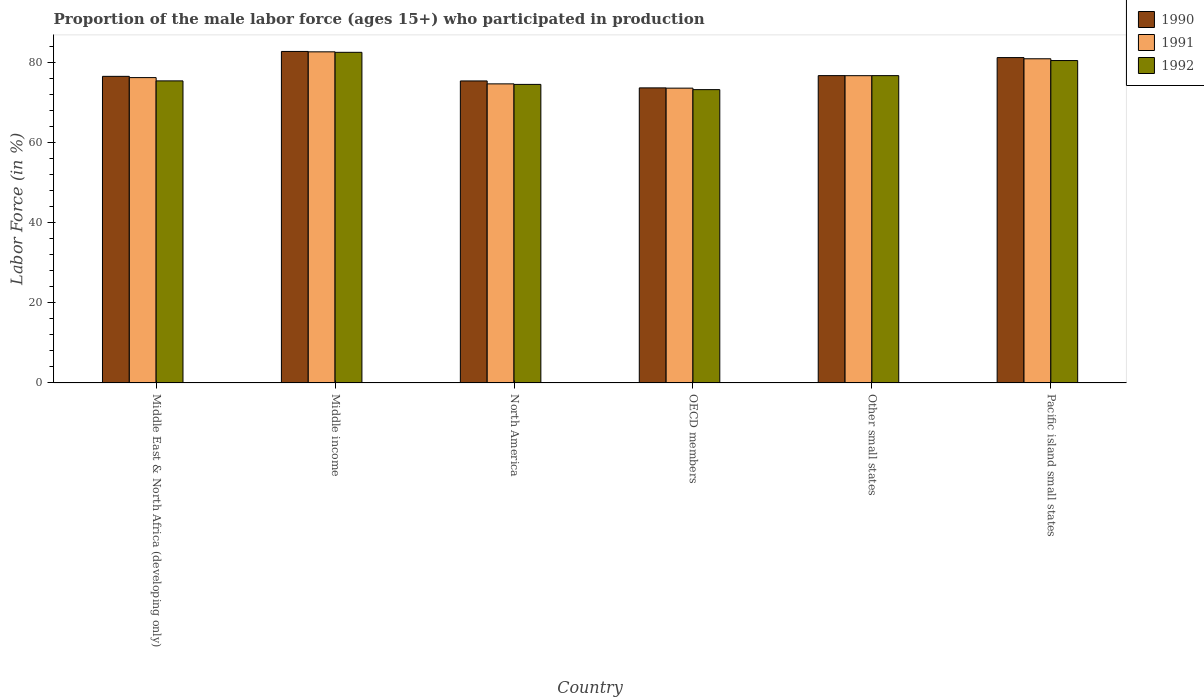How many groups of bars are there?
Provide a succinct answer. 6. How many bars are there on the 2nd tick from the left?
Give a very brief answer. 3. What is the label of the 6th group of bars from the left?
Your response must be concise. Pacific island small states. What is the proportion of the male labor force who participated in production in 1991 in Pacific island small states?
Ensure brevity in your answer.  81. Across all countries, what is the maximum proportion of the male labor force who participated in production in 1990?
Offer a terse response. 82.83. Across all countries, what is the minimum proportion of the male labor force who participated in production in 1990?
Keep it short and to the point. 73.73. What is the total proportion of the male labor force who participated in production in 1992 in the graph?
Your answer should be very brief. 463.32. What is the difference between the proportion of the male labor force who participated in production in 1991 in North America and that in Other small states?
Provide a succinct answer. -2.04. What is the difference between the proportion of the male labor force who participated in production in 1991 in OECD members and the proportion of the male labor force who participated in production in 1992 in North America?
Keep it short and to the point. -0.94. What is the average proportion of the male labor force who participated in production in 1990 per country?
Offer a very short reply. 77.79. What is the difference between the proportion of the male labor force who participated in production of/in 1990 and proportion of the male labor force who participated in production of/in 1992 in Middle East & North Africa (developing only)?
Provide a short and direct response. 1.13. In how many countries, is the proportion of the male labor force who participated in production in 1992 greater than 76 %?
Your answer should be compact. 3. What is the ratio of the proportion of the male labor force who participated in production in 1992 in Middle income to that in OECD members?
Your response must be concise. 1.13. Is the difference between the proportion of the male labor force who participated in production in 1990 in Other small states and Pacific island small states greater than the difference between the proportion of the male labor force who participated in production in 1992 in Other small states and Pacific island small states?
Offer a terse response. No. What is the difference between the highest and the second highest proportion of the male labor force who participated in production in 1990?
Ensure brevity in your answer.  -1.54. What is the difference between the highest and the lowest proportion of the male labor force who participated in production in 1991?
Your answer should be very brief. 9.07. How many countries are there in the graph?
Provide a succinct answer. 6. Are the values on the major ticks of Y-axis written in scientific E-notation?
Give a very brief answer. No. Does the graph contain any zero values?
Ensure brevity in your answer.  No. How are the legend labels stacked?
Offer a very short reply. Vertical. What is the title of the graph?
Give a very brief answer. Proportion of the male labor force (ages 15+) who participated in production. What is the Labor Force (in %) of 1990 in Middle East & North Africa (developing only)?
Offer a terse response. 76.61. What is the Labor Force (in %) of 1991 in Middle East & North Africa (developing only)?
Your answer should be very brief. 76.29. What is the Labor Force (in %) in 1992 in Middle East & North Africa (developing only)?
Keep it short and to the point. 75.48. What is the Labor Force (in %) in 1990 in Middle income?
Keep it short and to the point. 82.83. What is the Labor Force (in %) of 1991 in Middle income?
Ensure brevity in your answer.  82.73. What is the Labor Force (in %) of 1992 in Middle income?
Provide a succinct answer. 82.61. What is the Labor Force (in %) in 1990 in North America?
Keep it short and to the point. 75.46. What is the Labor Force (in %) in 1991 in North America?
Offer a terse response. 74.73. What is the Labor Force (in %) of 1992 in North America?
Your answer should be very brief. 74.6. What is the Labor Force (in %) in 1990 in OECD members?
Provide a succinct answer. 73.73. What is the Labor Force (in %) of 1991 in OECD members?
Provide a succinct answer. 73.66. What is the Labor Force (in %) of 1992 in OECD members?
Your response must be concise. 73.29. What is the Labor Force (in %) in 1990 in Other small states?
Keep it short and to the point. 76.79. What is the Labor Force (in %) of 1991 in Other small states?
Provide a succinct answer. 76.78. What is the Labor Force (in %) in 1992 in Other small states?
Offer a very short reply. 76.79. What is the Labor Force (in %) of 1990 in Pacific island small states?
Your answer should be very brief. 81.29. What is the Labor Force (in %) in 1991 in Pacific island small states?
Make the answer very short. 81. What is the Labor Force (in %) in 1992 in Pacific island small states?
Ensure brevity in your answer.  80.56. Across all countries, what is the maximum Labor Force (in %) in 1990?
Give a very brief answer. 82.83. Across all countries, what is the maximum Labor Force (in %) of 1991?
Your answer should be very brief. 82.73. Across all countries, what is the maximum Labor Force (in %) of 1992?
Make the answer very short. 82.61. Across all countries, what is the minimum Labor Force (in %) of 1990?
Provide a succinct answer. 73.73. Across all countries, what is the minimum Labor Force (in %) of 1991?
Give a very brief answer. 73.66. Across all countries, what is the minimum Labor Force (in %) in 1992?
Provide a succinct answer. 73.29. What is the total Labor Force (in %) of 1990 in the graph?
Offer a terse response. 466.71. What is the total Labor Force (in %) in 1991 in the graph?
Your answer should be very brief. 465.19. What is the total Labor Force (in %) in 1992 in the graph?
Keep it short and to the point. 463.32. What is the difference between the Labor Force (in %) in 1990 in Middle East & North Africa (developing only) and that in Middle income?
Provide a succinct answer. -6.22. What is the difference between the Labor Force (in %) of 1991 in Middle East & North Africa (developing only) and that in Middle income?
Provide a short and direct response. -6.44. What is the difference between the Labor Force (in %) of 1992 in Middle East & North Africa (developing only) and that in Middle income?
Offer a very short reply. -7.14. What is the difference between the Labor Force (in %) of 1990 in Middle East & North Africa (developing only) and that in North America?
Provide a short and direct response. 1.15. What is the difference between the Labor Force (in %) of 1991 in Middle East & North Africa (developing only) and that in North America?
Offer a terse response. 1.56. What is the difference between the Labor Force (in %) of 1992 in Middle East & North Africa (developing only) and that in North America?
Ensure brevity in your answer.  0.88. What is the difference between the Labor Force (in %) of 1990 in Middle East & North Africa (developing only) and that in OECD members?
Your response must be concise. 2.88. What is the difference between the Labor Force (in %) in 1991 in Middle East & North Africa (developing only) and that in OECD members?
Offer a very short reply. 2.64. What is the difference between the Labor Force (in %) in 1992 in Middle East & North Africa (developing only) and that in OECD members?
Your answer should be compact. 2.19. What is the difference between the Labor Force (in %) in 1990 in Middle East & North Africa (developing only) and that in Other small states?
Make the answer very short. -0.18. What is the difference between the Labor Force (in %) in 1991 in Middle East & North Africa (developing only) and that in Other small states?
Your response must be concise. -0.48. What is the difference between the Labor Force (in %) of 1992 in Middle East & North Africa (developing only) and that in Other small states?
Ensure brevity in your answer.  -1.31. What is the difference between the Labor Force (in %) in 1990 in Middle East & North Africa (developing only) and that in Pacific island small states?
Ensure brevity in your answer.  -4.69. What is the difference between the Labor Force (in %) in 1991 in Middle East & North Africa (developing only) and that in Pacific island small states?
Offer a very short reply. -4.71. What is the difference between the Labor Force (in %) of 1992 in Middle East & North Africa (developing only) and that in Pacific island small states?
Your response must be concise. -5.08. What is the difference between the Labor Force (in %) in 1990 in Middle income and that in North America?
Give a very brief answer. 7.37. What is the difference between the Labor Force (in %) in 1991 in Middle income and that in North America?
Your answer should be compact. 8. What is the difference between the Labor Force (in %) of 1992 in Middle income and that in North America?
Provide a short and direct response. 8.02. What is the difference between the Labor Force (in %) of 1990 in Middle income and that in OECD members?
Provide a succinct answer. 9.1. What is the difference between the Labor Force (in %) of 1991 in Middle income and that in OECD members?
Make the answer very short. 9.07. What is the difference between the Labor Force (in %) in 1992 in Middle income and that in OECD members?
Your response must be concise. 9.32. What is the difference between the Labor Force (in %) of 1990 in Middle income and that in Other small states?
Provide a short and direct response. 6.04. What is the difference between the Labor Force (in %) in 1991 in Middle income and that in Other small states?
Your answer should be compact. 5.96. What is the difference between the Labor Force (in %) in 1992 in Middle income and that in Other small states?
Your response must be concise. 5.83. What is the difference between the Labor Force (in %) of 1990 in Middle income and that in Pacific island small states?
Keep it short and to the point. 1.54. What is the difference between the Labor Force (in %) of 1991 in Middle income and that in Pacific island small states?
Keep it short and to the point. 1.73. What is the difference between the Labor Force (in %) of 1992 in Middle income and that in Pacific island small states?
Provide a short and direct response. 2.06. What is the difference between the Labor Force (in %) in 1990 in North America and that in OECD members?
Ensure brevity in your answer.  1.74. What is the difference between the Labor Force (in %) of 1991 in North America and that in OECD members?
Offer a very short reply. 1.07. What is the difference between the Labor Force (in %) of 1992 in North America and that in OECD members?
Keep it short and to the point. 1.31. What is the difference between the Labor Force (in %) in 1990 in North America and that in Other small states?
Provide a short and direct response. -1.33. What is the difference between the Labor Force (in %) in 1991 in North America and that in Other small states?
Make the answer very short. -2.04. What is the difference between the Labor Force (in %) of 1992 in North America and that in Other small states?
Offer a very short reply. -2.19. What is the difference between the Labor Force (in %) of 1990 in North America and that in Pacific island small states?
Keep it short and to the point. -5.83. What is the difference between the Labor Force (in %) of 1991 in North America and that in Pacific island small states?
Provide a succinct answer. -6.27. What is the difference between the Labor Force (in %) in 1992 in North America and that in Pacific island small states?
Provide a succinct answer. -5.96. What is the difference between the Labor Force (in %) in 1990 in OECD members and that in Other small states?
Your answer should be compact. -3.07. What is the difference between the Labor Force (in %) of 1991 in OECD members and that in Other small states?
Your answer should be compact. -3.12. What is the difference between the Labor Force (in %) in 1992 in OECD members and that in Other small states?
Your response must be concise. -3.5. What is the difference between the Labor Force (in %) in 1990 in OECD members and that in Pacific island small states?
Provide a short and direct response. -7.57. What is the difference between the Labor Force (in %) of 1991 in OECD members and that in Pacific island small states?
Give a very brief answer. -7.34. What is the difference between the Labor Force (in %) of 1992 in OECD members and that in Pacific island small states?
Offer a terse response. -7.27. What is the difference between the Labor Force (in %) in 1990 in Other small states and that in Pacific island small states?
Offer a very short reply. -4.5. What is the difference between the Labor Force (in %) in 1991 in Other small states and that in Pacific island small states?
Offer a terse response. -4.23. What is the difference between the Labor Force (in %) in 1992 in Other small states and that in Pacific island small states?
Offer a very short reply. -3.77. What is the difference between the Labor Force (in %) of 1990 in Middle East & North Africa (developing only) and the Labor Force (in %) of 1991 in Middle income?
Offer a terse response. -6.12. What is the difference between the Labor Force (in %) of 1990 in Middle East & North Africa (developing only) and the Labor Force (in %) of 1992 in Middle income?
Your response must be concise. -6. What is the difference between the Labor Force (in %) in 1991 in Middle East & North Africa (developing only) and the Labor Force (in %) in 1992 in Middle income?
Make the answer very short. -6.32. What is the difference between the Labor Force (in %) of 1990 in Middle East & North Africa (developing only) and the Labor Force (in %) of 1991 in North America?
Your response must be concise. 1.88. What is the difference between the Labor Force (in %) in 1990 in Middle East & North Africa (developing only) and the Labor Force (in %) in 1992 in North America?
Your answer should be compact. 2.01. What is the difference between the Labor Force (in %) in 1991 in Middle East & North Africa (developing only) and the Labor Force (in %) in 1992 in North America?
Offer a terse response. 1.7. What is the difference between the Labor Force (in %) of 1990 in Middle East & North Africa (developing only) and the Labor Force (in %) of 1991 in OECD members?
Your answer should be compact. 2.95. What is the difference between the Labor Force (in %) of 1990 in Middle East & North Africa (developing only) and the Labor Force (in %) of 1992 in OECD members?
Keep it short and to the point. 3.32. What is the difference between the Labor Force (in %) of 1991 in Middle East & North Africa (developing only) and the Labor Force (in %) of 1992 in OECD members?
Your answer should be very brief. 3.01. What is the difference between the Labor Force (in %) of 1990 in Middle East & North Africa (developing only) and the Labor Force (in %) of 1991 in Other small states?
Your answer should be compact. -0.17. What is the difference between the Labor Force (in %) in 1990 in Middle East & North Africa (developing only) and the Labor Force (in %) in 1992 in Other small states?
Keep it short and to the point. -0.18. What is the difference between the Labor Force (in %) of 1991 in Middle East & North Africa (developing only) and the Labor Force (in %) of 1992 in Other small states?
Give a very brief answer. -0.49. What is the difference between the Labor Force (in %) of 1990 in Middle East & North Africa (developing only) and the Labor Force (in %) of 1991 in Pacific island small states?
Your answer should be very brief. -4.39. What is the difference between the Labor Force (in %) of 1990 in Middle East & North Africa (developing only) and the Labor Force (in %) of 1992 in Pacific island small states?
Offer a terse response. -3.95. What is the difference between the Labor Force (in %) in 1991 in Middle East & North Africa (developing only) and the Labor Force (in %) in 1992 in Pacific island small states?
Keep it short and to the point. -4.26. What is the difference between the Labor Force (in %) in 1990 in Middle income and the Labor Force (in %) in 1991 in North America?
Your response must be concise. 8.1. What is the difference between the Labor Force (in %) of 1990 in Middle income and the Labor Force (in %) of 1992 in North America?
Ensure brevity in your answer.  8.23. What is the difference between the Labor Force (in %) in 1991 in Middle income and the Labor Force (in %) in 1992 in North America?
Ensure brevity in your answer.  8.14. What is the difference between the Labor Force (in %) of 1990 in Middle income and the Labor Force (in %) of 1991 in OECD members?
Give a very brief answer. 9.17. What is the difference between the Labor Force (in %) of 1990 in Middle income and the Labor Force (in %) of 1992 in OECD members?
Keep it short and to the point. 9.54. What is the difference between the Labor Force (in %) of 1991 in Middle income and the Labor Force (in %) of 1992 in OECD members?
Offer a very short reply. 9.44. What is the difference between the Labor Force (in %) in 1990 in Middle income and the Labor Force (in %) in 1991 in Other small states?
Make the answer very short. 6.05. What is the difference between the Labor Force (in %) of 1990 in Middle income and the Labor Force (in %) of 1992 in Other small states?
Your answer should be compact. 6.04. What is the difference between the Labor Force (in %) of 1991 in Middle income and the Labor Force (in %) of 1992 in Other small states?
Your response must be concise. 5.94. What is the difference between the Labor Force (in %) in 1990 in Middle income and the Labor Force (in %) in 1991 in Pacific island small states?
Your answer should be very brief. 1.83. What is the difference between the Labor Force (in %) in 1990 in Middle income and the Labor Force (in %) in 1992 in Pacific island small states?
Offer a very short reply. 2.27. What is the difference between the Labor Force (in %) in 1991 in Middle income and the Labor Force (in %) in 1992 in Pacific island small states?
Offer a terse response. 2.18. What is the difference between the Labor Force (in %) in 1990 in North America and the Labor Force (in %) in 1991 in OECD members?
Provide a short and direct response. 1.8. What is the difference between the Labor Force (in %) of 1990 in North America and the Labor Force (in %) of 1992 in OECD members?
Provide a succinct answer. 2.17. What is the difference between the Labor Force (in %) in 1991 in North America and the Labor Force (in %) in 1992 in OECD members?
Make the answer very short. 1.44. What is the difference between the Labor Force (in %) in 1990 in North America and the Labor Force (in %) in 1991 in Other small states?
Provide a short and direct response. -1.31. What is the difference between the Labor Force (in %) in 1990 in North America and the Labor Force (in %) in 1992 in Other small states?
Make the answer very short. -1.33. What is the difference between the Labor Force (in %) in 1991 in North America and the Labor Force (in %) in 1992 in Other small states?
Make the answer very short. -2.06. What is the difference between the Labor Force (in %) in 1990 in North America and the Labor Force (in %) in 1991 in Pacific island small states?
Your answer should be compact. -5.54. What is the difference between the Labor Force (in %) in 1990 in North America and the Labor Force (in %) in 1992 in Pacific island small states?
Make the answer very short. -5.09. What is the difference between the Labor Force (in %) in 1991 in North America and the Labor Force (in %) in 1992 in Pacific island small states?
Provide a short and direct response. -5.82. What is the difference between the Labor Force (in %) of 1990 in OECD members and the Labor Force (in %) of 1991 in Other small states?
Offer a terse response. -3.05. What is the difference between the Labor Force (in %) in 1990 in OECD members and the Labor Force (in %) in 1992 in Other small states?
Your answer should be very brief. -3.06. What is the difference between the Labor Force (in %) in 1991 in OECD members and the Labor Force (in %) in 1992 in Other small states?
Offer a very short reply. -3.13. What is the difference between the Labor Force (in %) in 1990 in OECD members and the Labor Force (in %) in 1991 in Pacific island small states?
Make the answer very short. -7.27. What is the difference between the Labor Force (in %) of 1990 in OECD members and the Labor Force (in %) of 1992 in Pacific island small states?
Your answer should be compact. -6.83. What is the difference between the Labor Force (in %) in 1991 in OECD members and the Labor Force (in %) in 1992 in Pacific island small states?
Offer a very short reply. -6.9. What is the difference between the Labor Force (in %) of 1990 in Other small states and the Labor Force (in %) of 1991 in Pacific island small states?
Your response must be concise. -4.21. What is the difference between the Labor Force (in %) in 1990 in Other small states and the Labor Force (in %) in 1992 in Pacific island small states?
Give a very brief answer. -3.76. What is the difference between the Labor Force (in %) of 1991 in Other small states and the Labor Force (in %) of 1992 in Pacific island small states?
Your response must be concise. -3.78. What is the average Labor Force (in %) of 1990 per country?
Your answer should be very brief. 77.79. What is the average Labor Force (in %) in 1991 per country?
Offer a very short reply. 77.53. What is the average Labor Force (in %) in 1992 per country?
Offer a very short reply. 77.22. What is the difference between the Labor Force (in %) in 1990 and Labor Force (in %) in 1991 in Middle East & North Africa (developing only)?
Provide a succinct answer. 0.31. What is the difference between the Labor Force (in %) of 1990 and Labor Force (in %) of 1992 in Middle East & North Africa (developing only)?
Offer a very short reply. 1.13. What is the difference between the Labor Force (in %) of 1991 and Labor Force (in %) of 1992 in Middle East & North Africa (developing only)?
Offer a terse response. 0.82. What is the difference between the Labor Force (in %) in 1990 and Labor Force (in %) in 1991 in Middle income?
Ensure brevity in your answer.  0.1. What is the difference between the Labor Force (in %) of 1990 and Labor Force (in %) of 1992 in Middle income?
Ensure brevity in your answer.  0.22. What is the difference between the Labor Force (in %) in 1991 and Labor Force (in %) in 1992 in Middle income?
Ensure brevity in your answer.  0.12. What is the difference between the Labor Force (in %) in 1990 and Labor Force (in %) in 1991 in North America?
Provide a short and direct response. 0.73. What is the difference between the Labor Force (in %) in 1990 and Labor Force (in %) in 1992 in North America?
Provide a succinct answer. 0.86. What is the difference between the Labor Force (in %) in 1991 and Labor Force (in %) in 1992 in North America?
Ensure brevity in your answer.  0.13. What is the difference between the Labor Force (in %) in 1990 and Labor Force (in %) in 1991 in OECD members?
Offer a terse response. 0.07. What is the difference between the Labor Force (in %) in 1990 and Labor Force (in %) in 1992 in OECD members?
Give a very brief answer. 0.44. What is the difference between the Labor Force (in %) of 1991 and Labor Force (in %) of 1992 in OECD members?
Provide a succinct answer. 0.37. What is the difference between the Labor Force (in %) in 1990 and Labor Force (in %) in 1991 in Other small states?
Provide a short and direct response. 0.02. What is the difference between the Labor Force (in %) of 1990 and Labor Force (in %) of 1992 in Other small states?
Provide a succinct answer. 0. What is the difference between the Labor Force (in %) in 1991 and Labor Force (in %) in 1992 in Other small states?
Offer a very short reply. -0.01. What is the difference between the Labor Force (in %) of 1990 and Labor Force (in %) of 1991 in Pacific island small states?
Your answer should be very brief. 0.29. What is the difference between the Labor Force (in %) in 1990 and Labor Force (in %) in 1992 in Pacific island small states?
Your response must be concise. 0.74. What is the difference between the Labor Force (in %) in 1991 and Labor Force (in %) in 1992 in Pacific island small states?
Ensure brevity in your answer.  0.44. What is the ratio of the Labor Force (in %) in 1990 in Middle East & North Africa (developing only) to that in Middle income?
Give a very brief answer. 0.92. What is the ratio of the Labor Force (in %) in 1991 in Middle East & North Africa (developing only) to that in Middle income?
Give a very brief answer. 0.92. What is the ratio of the Labor Force (in %) in 1992 in Middle East & North Africa (developing only) to that in Middle income?
Your answer should be compact. 0.91. What is the ratio of the Labor Force (in %) of 1990 in Middle East & North Africa (developing only) to that in North America?
Provide a succinct answer. 1.02. What is the ratio of the Labor Force (in %) of 1991 in Middle East & North Africa (developing only) to that in North America?
Offer a very short reply. 1.02. What is the ratio of the Labor Force (in %) of 1992 in Middle East & North Africa (developing only) to that in North America?
Provide a succinct answer. 1.01. What is the ratio of the Labor Force (in %) of 1990 in Middle East & North Africa (developing only) to that in OECD members?
Provide a short and direct response. 1.04. What is the ratio of the Labor Force (in %) in 1991 in Middle East & North Africa (developing only) to that in OECD members?
Your answer should be compact. 1.04. What is the ratio of the Labor Force (in %) in 1992 in Middle East & North Africa (developing only) to that in OECD members?
Your answer should be very brief. 1.03. What is the ratio of the Labor Force (in %) in 1991 in Middle East & North Africa (developing only) to that in Other small states?
Provide a short and direct response. 0.99. What is the ratio of the Labor Force (in %) of 1992 in Middle East & North Africa (developing only) to that in Other small states?
Your answer should be very brief. 0.98. What is the ratio of the Labor Force (in %) of 1990 in Middle East & North Africa (developing only) to that in Pacific island small states?
Offer a terse response. 0.94. What is the ratio of the Labor Force (in %) of 1991 in Middle East & North Africa (developing only) to that in Pacific island small states?
Your answer should be very brief. 0.94. What is the ratio of the Labor Force (in %) of 1992 in Middle East & North Africa (developing only) to that in Pacific island small states?
Ensure brevity in your answer.  0.94. What is the ratio of the Labor Force (in %) in 1990 in Middle income to that in North America?
Provide a short and direct response. 1.1. What is the ratio of the Labor Force (in %) of 1991 in Middle income to that in North America?
Ensure brevity in your answer.  1.11. What is the ratio of the Labor Force (in %) of 1992 in Middle income to that in North America?
Offer a terse response. 1.11. What is the ratio of the Labor Force (in %) of 1990 in Middle income to that in OECD members?
Give a very brief answer. 1.12. What is the ratio of the Labor Force (in %) of 1991 in Middle income to that in OECD members?
Make the answer very short. 1.12. What is the ratio of the Labor Force (in %) in 1992 in Middle income to that in OECD members?
Give a very brief answer. 1.13. What is the ratio of the Labor Force (in %) of 1990 in Middle income to that in Other small states?
Give a very brief answer. 1.08. What is the ratio of the Labor Force (in %) in 1991 in Middle income to that in Other small states?
Make the answer very short. 1.08. What is the ratio of the Labor Force (in %) in 1992 in Middle income to that in Other small states?
Provide a succinct answer. 1.08. What is the ratio of the Labor Force (in %) in 1990 in Middle income to that in Pacific island small states?
Make the answer very short. 1.02. What is the ratio of the Labor Force (in %) in 1991 in Middle income to that in Pacific island small states?
Your answer should be compact. 1.02. What is the ratio of the Labor Force (in %) of 1992 in Middle income to that in Pacific island small states?
Your answer should be very brief. 1.03. What is the ratio of the Labor Force (in %) in 1990 in North America to that in OECD members?
Make the answer very short. 1.02. What is the ratio of the Labor Force (in %) in 1991 in North America to that in OECD members?
Provide a short and direct response. 1.01. What is the ratio of the Labor Force (in %) in 1992 in North America to that in OECD members?
Your answer should be compact. 1.02. What is the ratio of the Labor Force (in %) of 1990 in North America to that in Other small states?
Give a very brief answer. 0.98. What is the ratio of the Labor Force (in %) of 1991 in North America to that in Other small states?
Your response must be concise. 0.97. What is the ratio of the Labor Force (in %) of 1992 in North America to that in Other small states?
Your answer should be very brief. 0.97. What is the ratio of the Labor Force (in %) of 1990 in North America to that in Pacific island small states?
Keep it short and to the point. 0.93. What is the ratio of the Labor Force (in %) of 1991 in North America to that in Pacific island small states?
Offer a very short reply. 0.92. What is the ratio of the Labor Force (in %) in 1992 in North America to that in Pacific island small states?
Offer a terse response. 0.93. What is the ratio of the Labor Force (in %) of 1990 in OECD members to that in Other small states?
Offer a terse response. 0.96. What is the ratio of the Labor Force (in %) in 1991 in OECD members to that in Other small states?
Your answer should be very brief. 0.96. What is the ratio of the Labor Force (in %) of 1992 in OECD members to that in Other small states?
Make the answer very short. 0.95. What is the ratio of the Labor Force (in %) of 1990 in OECD members to that in Pacific island small states?
Give a very brief answer. 0.91. What is the ratio of the Labor Force (in %) of 1991 in OECD members to that in Pacific island small states?
Keep it short and to the point. 0.91. What is the ratio of the Labor Force (in %) in 1992 in OECD members to that in Pacific island small states?
Offer a very short reply. 0.91. What is the ratio of the Labor Force (in %) of 1990 in Other small states to that in Pacific island small states?
Your answer should be compact. 0.94. What is the ratio of the Labor Force (in %) in 1991 in Other small states to that in Pacific island small states?
Your answer should be very brief. 0.95. What is the ratio of the Labor Force (in %) in 1992 in Other small states to that in Pacific island small states?
Your answer should be very brief. 0.95. What is the difference between the highest and the second highest Labor Force (in %) of 1990?
Keep it short and to the point. 1.54. What is the difference between the highest and the second highest Labor Force (in %) in 1991?
Provide a short and direct response. 1.73. What is the difference between the highest and the second highest Labor Force (in %) of 1992?
Provide a short and direct response. 2.06. What is the difference between the highest and the lowest Labor Force (in %) in 1990?
Give a very brief answer. 9.1. What is the difference between the highest and the lowest Labor Force (in %) in 1991?
Give a very brief answer. 9.07. What is the difference between the highest and the lowest Labor Force (in %) of 1992?
Your answer should be compact. 9.32. 